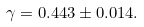Convert formula to latex. <formula><loc_0><loc_0><loc_500><loc_500>\gamma = 0 . 4 4 3 \pm 0 . 0 1 4 .</formula> 